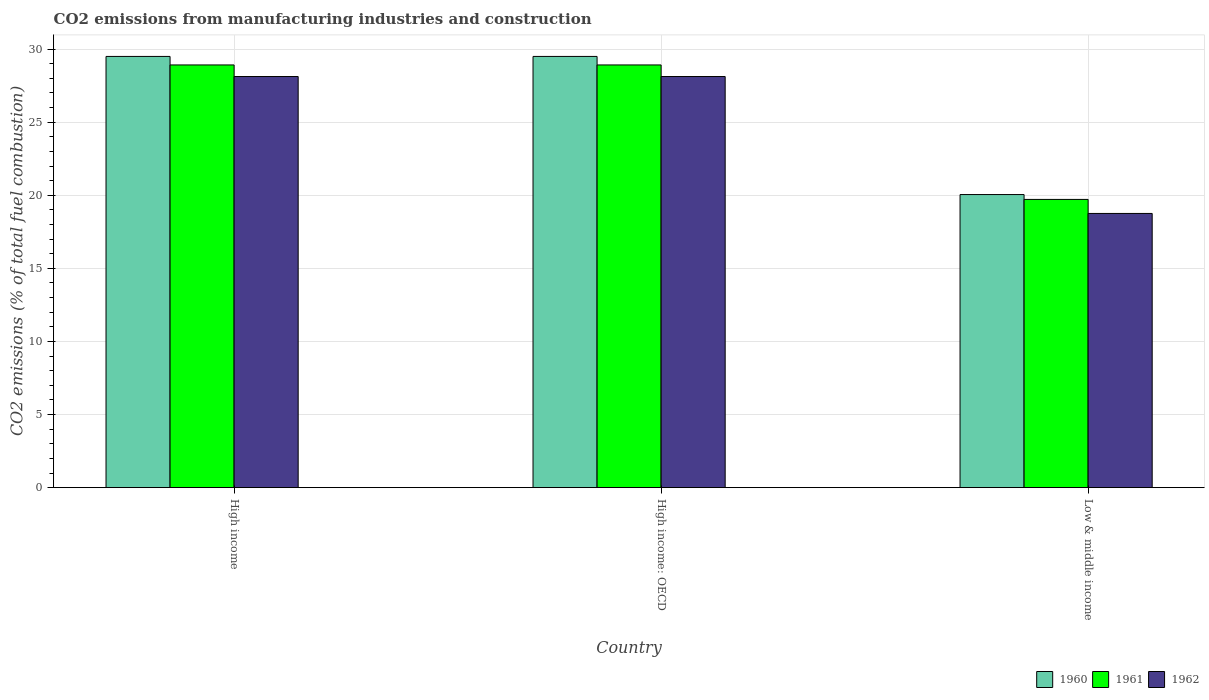Are the number of bars per tick equal to the number of legend labels?
Offer a terse response. Yes. Are the number of bars on each tick of the X-axis equal?
Make the answer very short. Yes. How many bars are there on the 3rd tick from the left?
Provide a short and direct response. 3. How many bars are there on the 3rd tick from the right?
Your answer should be very brief. 3. What is the label of the 1st group of bars from the left?
Make the answer very short. High income. In how many cases, is the number of bars for a given country not equal to the number of legend labels?
Give a very brief answer. 0. What is the amount of CO2 emitted in 1962 in High income?
Ensure brevity in your answer.  28.12. Across all countries, what is the maximum amount of CO2 emitted in 1960?
Offer a terse response. 29.5. Across all countries, what is the minimum amount of CO2 emitted in 1960?
Make the answer very short. 20.05. In which country was the amount of CO2 emitted in 1962 maximum?
Provide a short and direct response. High income. What is the total amount of CO2 emitted in 1960 in the graph?
Keep it short and to the point. 79.04. What is the difference between the amount of CO2 emitted in 1961 in High income and that in Low & middle income?
Ensure brevity in your answer.  9.2. What is the difference between the amount of CO2 emitted in 1962 in Low & middle income and the amount of CO2 emitted in 1960 in High income: OECD?
Keep it short and to the point. -10.74. What is the average amount of CO2 emitted in 1962 per country?
Your answer should be very brief. 25. What is the difference between the amount of CO2 emitted of/in 1960 and amount of CO2 emitted of/in 1962 in High income?
Provide a succinct answer. 1.37. What is the ratio of the amount of CO2 emitted in 1961 in High income to that in High income: OECD?
Make the answer very short. 1. What is the difference between the highest and the second highest amount of CO2 emitted in 1961?
Give a very brief answer. -9.2. What is the difference between the highest and the lowest amount of CO2 emitted in 1961?
Keep it short and to the point. 9.2. Is the sum of the amount of CO2 emitted in 1962 in High income and Low & middle income greater than the maximum amount of CO2 emitted in 1961 across all countries?
Keep it short and to the point. Yes. Is it the case that in every country, the sum of the amount of CO2 emitted in 1961 and amount of CO2 emitted in 1962 is greater than the amount of CO2 emitted in 1960?
Provide a short and direct response. Yes. How many bars are there?
Offer a very short reply. 9. Are the values on the major ticks of Y-axis written in scientific E-notation?
Keep it short and to the point. No. Where does the legend appear in the graph?
Make the answer very short. Bottom right. How many legend labels are there?
Offer a very short reply. 3. What is the title of the graph?
Ensure brevity in your answer.  CO2 emissions from manufacturing industries and construction. What is the label or title of the Y-axis?
Offer a very short reply. CO2 emissions (% of total fuel combustion). What is the CO2 emissions (% of total fuel combustion) of 1960 in High income?
Offer a terse response. 29.5. What is the CO2 emissions (% of total fuel combustion) in 1961 in High income?
Ensure brevity in your answer.  28.92. What is the CO2 emissions (% of total fuel combustion) of 1962 in High income?
Your answer should be compact. 28.12. What is the CO2 emissions (% of total fuel combustion) in 1960 in High income: OECD?
Your response must be concise. 29.5. What is the CO2 emissions (% of total fuel combustion) in 1961 in High income: OECD?
Your response must be concise. 28.92. What is the CO2 emissions (% of total fuel combustion) in 1962 in High income: OECD?
Offer a terse response. 28.12. What is the CO2 emissions (% of total fuel combustion) of 1960 in Low & middle income?
Provide a short and direct response. 20.05. What is the CO2 emissions (% of total fuel combustion) in 1961 in Low & middle income?
Provide a short and direct response. 19.72. What is the CO2 emissions (% of total fuel combustion) of 1962 in Low & middle income?
Offer a terse response. 18.76. Across all countries, what is the maximum CO2 emissions (% of total fuel combustion) in 1960?
Ensure brevity in your answer.  29.5. Across all countries, what is the maximum CO2 emissions (% of total fuel combustion) in 1961?
Ensure brevity in your answer.  28.92. Across all countries, what is the maximum CO2 emissions (% of total fuel combustion) in 1962?
Provide a succinct answer. 28.12. Across all countries, what is the minimum CO2 emissions (% of total fuel combustion) of 1960?
Offer a very short reply. 20.05. Across all countries, what is the minimum CO2 emissions (% of total fuel combustion) in 1961?
Ensure brevity in your answer.  19.72. Across all countries, what is the minimum CO2 emissions (% of total fuel combustion) of 1962?
Make the answer very short. 18.76. What is the total CO2 emissions (% of total fuel combustion) of 1960 in the graph?
Make the answer very short. 79.04. What is the total CO2 emissions (% of total fuel combustion) in 1961 in the graph?
Keep it short and to the point. 77.55. What is the total CO2 emissions (% of total fuel combustion) of 1962 in the graph?
Keep it short and to the point. 75. What is the difference between the CO2 emissions (% of total fuel combustion) in 1960 in High income and that in High income: OECD?
Provide a short and direct response. 0. What is the difference between the CO2 emissions (% of total fuel combustion) of 1961 in High income and that in High income: OECD?
Offer a very short reply. 0. What is the difference between the CO2 emissions (% of total fuel combustion) in 1960 in High income and that in Low & middle income?
Offer a very short reply. 9.45. What is the difference between the CO2 emissions (% of total fuel combustion) of 1961 in High income and that in Low & middle income?
Your response must be concise. 9.2. What is the difference between the CO2 emissions (% of total fuel combustion) of 1962 in High income and that in Low & middle income?
Give a very brief answer. 9.37. What is the difference between the CO2 emissions (% of total fuel combustion) of 1960 in High income: OECD and that in Low & middle income?
Offer a very short reply. 9.45. What is the difference between the CO2 emissions (% of total fuel combustion) in 1961 in High income: OECD and that in Low & middle income?
Provide a succinct answer. 9.2. What is the difference between the CO2 emissions (% of total fuel combustion) of 1962 in High income: OECD and that in Low & middle income?
Make the answer very short. 9.37. What is the difference between the CO2 emissions (% of total fuel combustion) in 1960 in High income and the CO2 emissions (% of total fuel combustion) in 1961 in High income: OECD?
Provide a short and direct response. 0.58. What is the difference between the CO2 emissions (% of total fuel combustion) in 1960 in High income and the CO2 emissions (% of total fuel combustion) in 1962 in High income: OECD?
Keep it short and to the point. 1.37. What is the difference between the CO2 emissions (% of total fuel combustion) of 1961 in High income and the CO2 emissions (% of total fuel combustion) of 1962 in High income: OECD?
Give a very brief answer. 0.79. What is the difference between the CO2 emissions (% of total fuel combustion) in 1960 in High income and the CO2 emissions (% of total fuel combustion) in 1961 in Low & middle income?
Offer a very short reply. 9.78. What is the difference between the CO2 emissions (% of total fuel combustion) in 1960 in High income and the CO2 emissions (% of total fuel combustion) in 1962 in Low & middle income?
Your response must be concise. 10.74. What is the difference between the CO2 emissions (% of total fuel combustion) of 1961 in High income and the CO2 emissions (% of total fuel combustion) of 1962 in Low & middle income?
Your response must be concise. 10.16. What is the difference between the CO2 emissions (% of total fuel combustion) of 1960 in High income: OECD and the CO2 emissions (% of total fuel combustion) of 1961 in Low & middle income?
Provide a succinct answer. 9.78. What is the difference between the CO2 emissions (% of total fuel combustion) of 1960 in High income: OECD and the CO2 emissions (% of total fuel combustion) of 1962 in Low & middle income?
Give a very brief answer. 10.74. What is the difference between the CO2 emissions (% of total fuel combustion) of 1961 in High income: OECD and the CO2 emissions (% of total fuel combustion) of 1962 in Low & middle income?
Offer a terse response. 10.16. What is the average CO2 emissions (% of total fuel combustion) of 1960 per country?
Offer a terse response. 26.35. What is the average CO2 emissions (% of total fuel combustion) in 1961 per country?
Ensure brevity in your answer.  25.85. What is the average CO2 emissions (% of total fuel combustion) of 1962 per country?
Your answer should be compact. 25. What is the difference between the CO2 emissions (% of total fuel combustion) of 1960 and CO2 emissions (% of total fuel combustion) of 1961 in High income?
Provide a succinct answer. 0.58. What is the difference between the CO2 emissions (% of total fuel combustion) of 1960 and CO2 emissions (% of total fuel combustion) of 1962 in High income?
Keep it short and to the point. 1.37. What is the difference between the CO2 emissions (% of total fuel combustion) of 1961 and CO2 emissions (% of total fuel combustion) of 1962 in High income?
Offer a terse response. 0.79. What is the difference between the CO2 emissions (% of total fuel combustion) of 1960 and CO2 emissions (% of total fuel combustion) of 1961 in High income: OECD?
Offer a very short reply. 0.58. What is the difference between the CO2 emissions (% of total fuel combustion) of 1960 and CO2 emissions (% of total fuel combustion) of 1962 in High income: OECD?
Offer a terse response. 1.37. What is the difference between the CO2 emissions (% of total fuel combustion) in 1961 and CO2 emissions (% of total fuel combustion) in 1962 in High income: OECD?
Offer a terse response. 0.79. What is the difference between the CO2 emissions (% of total fuel combustion) in 1960 and CO2 emissions (% of total fuel combustion) in 1961 in Low & middle income?
Offer a terse response. 0.33. What is the difference between the CO2 emissions (% of total fuel combustion) of 1960 and CO2 emissions (% of total fuel combustion) of 1962 in Low & middle income?
Offer a terse response. 1.29. What is the difference between the CO2 emissions (% of total fuel combustion) of 1961 and CO2 emissions (% of total fuel combustion) of 1962 in Low & middle income?
Give a very brief answer. 0.96. What is the ratio of the CO2 emissions (% of total fuel combustion) of 1960 in High income to that in High income: OECD?
Provide a short and direct response. 1. What is the ratio of the CO2 emissions (% of total fuel combustion) in 1961 in High income to that in High income: OECD?
Make the answer very short. 1. What is the ratio of the CO2 emissions (% of total fuel combustion) of 1962 in High income to that in High income: OECD?
Your answer should be very brief. 1. What is the ratio of the CO2 emissions (% of total fuel combustion) of 1960 in High income to that in Low & middle income?
Make the answer very short. 1.47. What is the ratio of the CO2 emissions (% of total fuel combustion) in 1961 in High income to that in Low & middle income?
Ensure brevity in your answer.  1.47. What is the ratio of the CO2 emissions (% of total fuel combustion) of 1962 in High income to that in Low & middle income?
Your answer should be compact. 1.5. What is the ratio of the CO2 emissions (% of total fuel combustion) of 1960 in High income: OECD to that in Low & middle income?
Keep it short and to the point. 1.47. What is the ratio of the CO2 emissions (% of total fuel combustion) in 1961 in High income: OECD to that in Low & middle income?
Keep it short and to the point. 1.47. What is the ratio of the CO2 emissions (% of total fuel combustion) in 1962 in High income: OECD to that in Low & middle income?
Provide a short and direct response. 1.5. What is the difference between the highest and the second highest CO2 emissions (% of total fuel combustion) in 1960?
Your answer should be compact. 0. What is the difference between the highest and the lowest CO2 emissions (% of total fuel combustion) of 1960?
Offer a very short reply. 9.45. What is the difference between the highest and the lowest CO2 emissions (% of total fuel combustion) of 1961?
Your answer should be compact. 9.2. What is the difference between the highest and the lowest CO2 emissions (% of total fuel combustion) of 1962?
Your answer should be compact. 9.37. 